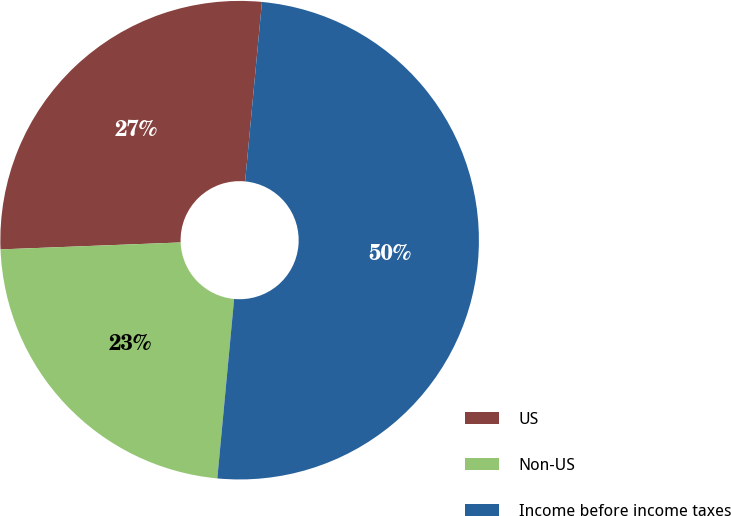Convert chart. <chart><loc_0><loc_0><loc_500><loc_500><pie_chart><fcel>US<fcel>Non-US<fcel>Income before income taxes<nl><fcel>27.1%<fcel>22.9%<fcel>50.0%<nl></chart> 